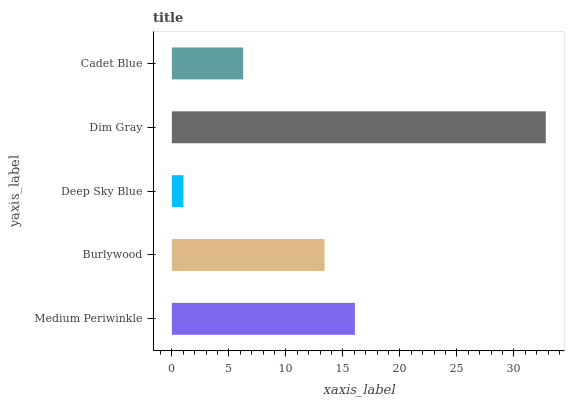Is Deep Sky Blue the minimum?
Answer yes or no. Yes. Is Dim Gray the maximum?
Answer yes or no. Yes. Is Burlywood the minimum?
Answer yes or no. No. Is Burlywood the maximum?
Answer yes or no. No. Is Medium Periwinkle greater than Burlywood?
Answer yes or no. Yes. Is Burlywood less than Medium Periwinkle?
Answer yes or no. Yes. Is Burlywood greater than Medium Periwinkle?
Answer yes or no. No. Is Medium Periwinkle less than Burlywood?
Answer yes or no. No. Is Burlywood the high median?
Answer yes or no. Yes. Is Burlywood the low median?
Answer yes or no. Yes. Is Medium Periwinkle the high median?
Answer yes or no. No. Is Cadet Blue the low median?
Answer yes or no. No. 